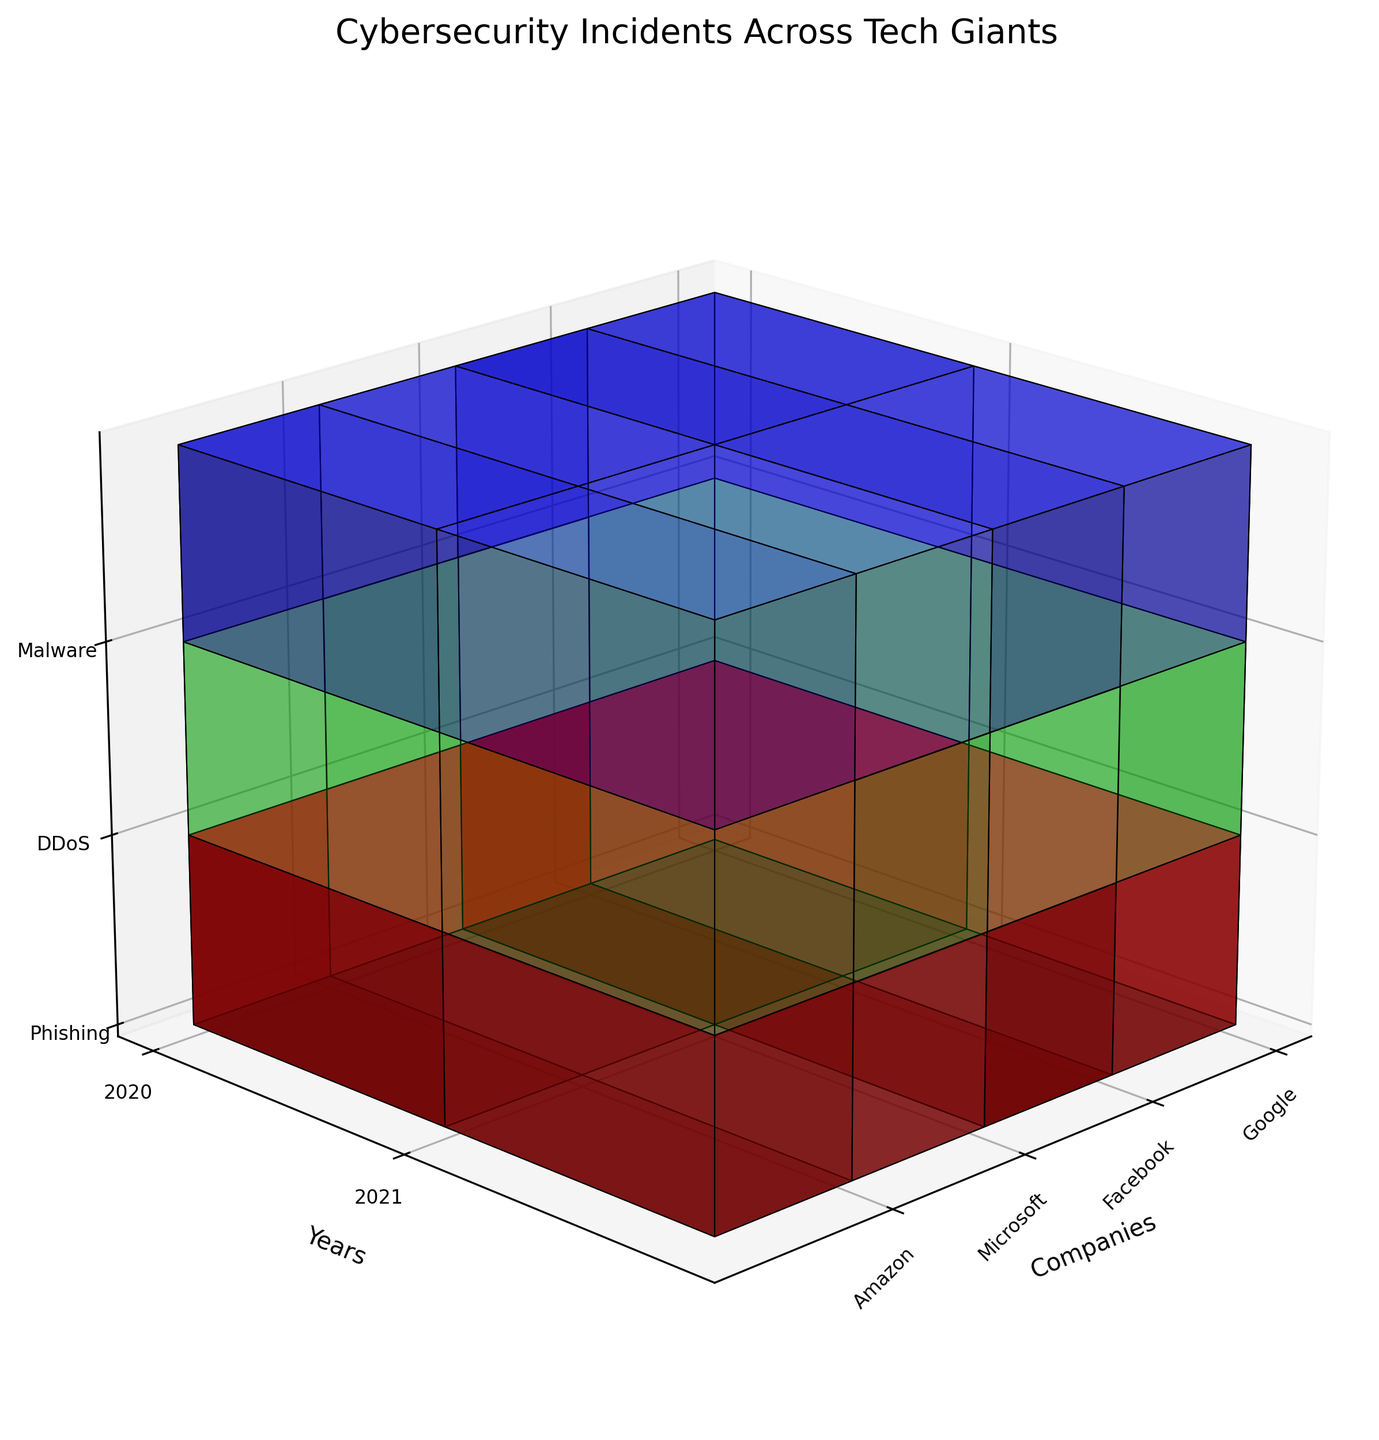What's the title of the figure? The title is displayed at the top of the plot and gives a high-level summary of the data being visualized.
Answer: Cybersecurity Incidents Across Tech Giants Which company had the most phishing incidents in 2020? To find the company with the most phishing incidents in 2020, check the color intensity for the red (phishing) blocks for each company in 2020. Facebook's red block in 2020 is most intense, indicating the highest number.
Answer: Facebook What is the sum of DDoS incidents for Google and Facebook in 2021? Sum up the green (DDoS) voxels for Google and Facebook in 2021. Google has 80, and Facebook has 70, resulting in a sum of 150 incidents.
Answer: 150 Which attack type had the lowest incident rate for Microsoft in 2021? Compare the color intensities of the three types of attacks (red: phishing, green: DDoS, blue: malware) for Microsoft in 2021. The blue block for malware is the least intense.
Answer: Malware How did Amazon's phishing incidents change from 2020 to 2021? Compare the red (phishing) voxels for Amazon between 2020 and 2021. The intensity decreases from 160 to 140 incidents.
Answer: Decreased Which company saw the biggest drop in malware incidents from 2020 to 2021? Check the blue (malware) voxels for each company from 2020 to 2021 and notice the intensity changes. Microsoft's malware incidents dropped from 95 to 85, the largest decrease.
Answer: Microsoft How many total cybersecurity incidents did Facebook have in 2020? Sum up the incident counts represented by the red (phishing), green (DDoS), and blue (malware) voxels for Facebook in 2020. Their values add up to 180 (phishing) + 60 (DDoS) + 120 (malware) = 360.
Answer: 360 Which company had a higher number of DDoS incidents in 2021, Facebook or Amazon? Compare the green (DDoS) voxels for Facebook and Amazon in 2021. Facebook had 70, and Amazon had 75 incidents; thus, Amazon is higher.
Answer: Amazon What is the average number of malware incidents for all companies in 2020? Add up all the malware incidents in 2020 and divide by the number of companies. The totals are 100 (Google) + 120 (Facebook) + 95 (Microsoft) + 110 (Amazon) = 425. There are 4 companies, so 425 / 4 = 106.25.
Answer: 106.25 Which attack type generally has the highest incident rates across the companies? By observing overall color intensities, the red (phishing) blocks appear most intense across companies and years, indicating phishing generally has the highest incident rates.
Answer: Phishing 